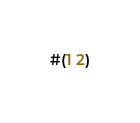<code> <loc_0><loc_0><loc_500><loc_500><_Scheme_>#(1 2)</code> 